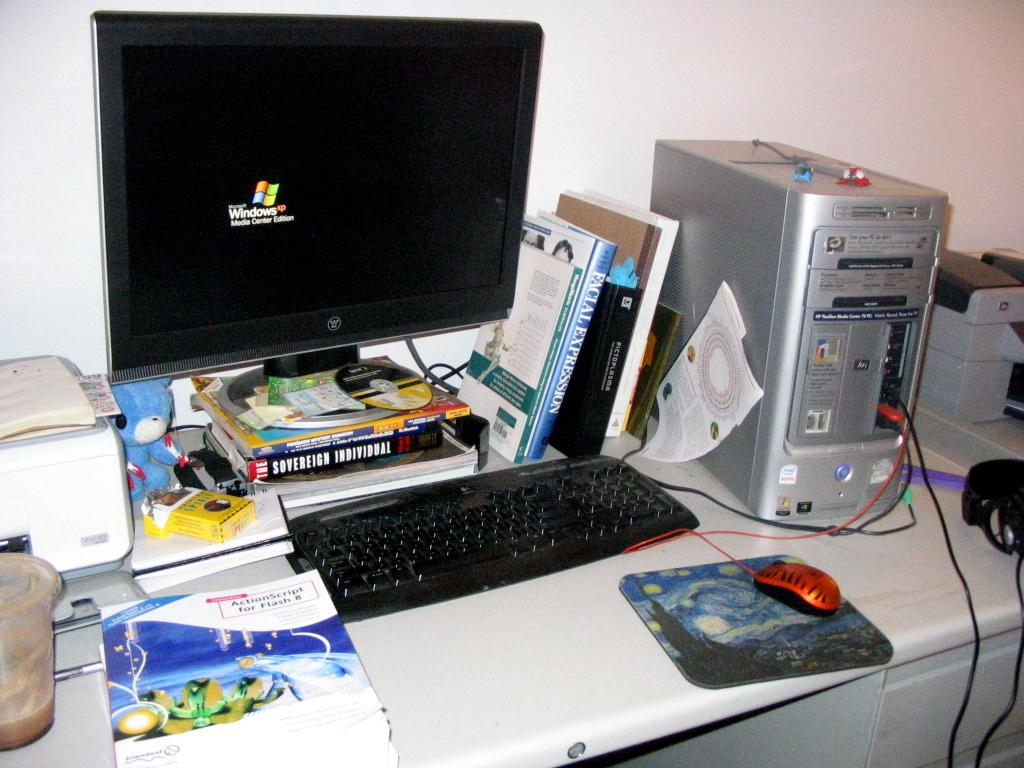<image>
Render a clear and concise summary of the photo. A computer monitor is on a stack of books including one called The Sovereign Individual. 